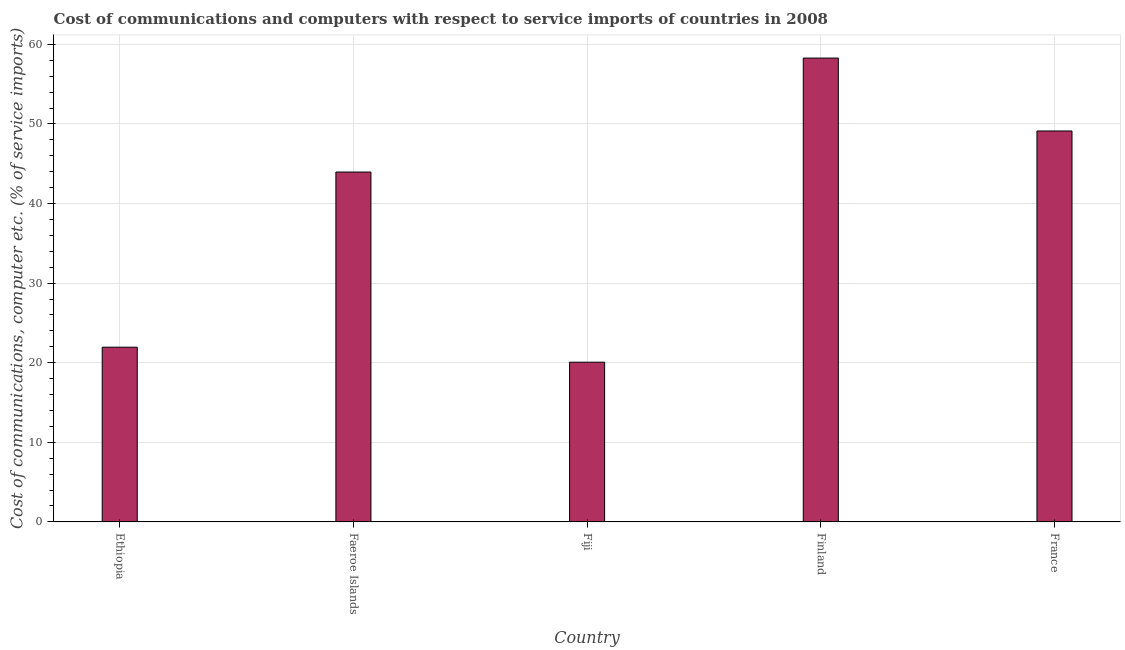Does the graph contain grids?
Give a very brief answer. Yes. What is the title of the graph?
Make the answer very short. Cost of communications and computers with respect to service imports of countries in 2008. What is the label or title of the X-axis?
Ensure brevity in your answer.  Country. What is the label or title of the Y-axis?
Provide a short and direct response. Cost of communications, computer etc. (% of service imports). What is the cost of communications and computer in Fiji?
Provide a succinct answer. 20.07. Across all countries, what is the maximum cost of communications and computer?
Your response must be concise. 58.28. Across all countries, what is the minimum cost of communications and computer?
Provide a short and direct response. 20.07. In which country was the cost of communications and computer minimum?
Offer a very short reply. Fiji. What is the sum of the cost of communications and computer?
Offer a very short reply. 193.37. What is the difference between the cost of communications and computer in Faeroe Islands and France?
Your response must be concise. -5.16. What is the average cost of communications and computer per country?
Offer a very short reply. 38.67. What is the median cost of communications and computer?
Your response must be concise. 43.96. In how many countries, is the cost of communications and computer greater than 38 %?
Offer a very short reply. 3. What is the ratio of the cost of communications and computer in Ethiopia to that in Finland?
Provide a succinct answer. 0.38. Is the cost of communications and computer in Faeroe Islands less than that in Finland?
Offer a terse response. Yes. Is the difference between the cost of communications and computer in Faeroe Islands and Finland greater than the difference between any two countries?
Give a very brief answer. No. What is the difference between the highest and the second highest cost of communications and computer?
Offer a terse response. 9.16. What is the difference between the highest and the lowest cost of communications and computer?
Provide a short and direct response. 38.21. How many bars are there?
Keep it short and to the point. 5. Are all the bars in the graph horizontal?
Offer a very short reply. No. How many countries are there in the graph?
Make the answer very short. 5. What is the Cost of communications, computer etc. (% of service imports) in Ethiopia?
Provide a short and direct response. 21.95. What is the Cost of communications, computer etc. (% of service imports) of Faeroe Islands?
Provide a succinct answer. 43.96. What is the Cost of communications, computer etc. (% of service imports) in Fiji?
Offer a terse response. 20.07. What is the Cost of communications, computer etc. (% of service imports) in Finland?
Your answer should be very brief. 58.28. What is the Cost of communications, computer etc. (% of service imports) in France?
Offer a terse response. 49.12. What is the difference between the Cost of communications, computer etc. (% of service imports) in Ethiopia and Faeroe Islands?
Give a very brief answer. -22. What is the difference between the Cost of communications, computer etc. (% of service imports) in Ethiopia and Fiji?
Give a very brief answer. 1.88. What is the difference between the Cost of communications, computer etc. (% of service imports) in Ethiopia and Finland?
Your response must be concise. -36.32. What is the difference between the Cost of communications, computer etc. (% of service imports) in Ethiopia and France?
Offer a very short reply. -27.16. What is the difference between the Cost of communications, computer etc. (% of service imports) in Faeroe Islands and Fiji?
Give a very brief answer. 23.89. What is the difference between the Cost of communications, computer etc. (% of service imports) in Faeroe Islands and Finland?
Offer a terse response. -14.32. What is the difference between the Cost of communications, computer etc. (% of service imports) in Faeroe Islands and France?
Offer a very short reply. -5.16. What is the difference between the Cost of communications, computer etc. (% of service imports) in Fiji and Finland?
Offer a very short reply. -38.21. What is the difference between the Cost of communications, computer etc. (% of service imports) in Fiji and France?
Keep it short and to the point. -29.05. What is the difference between the Cost of communications, computer etc. (% of service imports) in Finland and France?
Offer a very short reply. 9.16. What is the ratio of the Cost of communications, computer etc. (% of service imports) in Ethiopia to that in Faeroe Islands?
Keep it short and to the point. 0.5. What is the ratio of the Cost of communications, computer etc. (% of service imports) in Ethiopia to that in Fiji?
Your response must be concise. 1.09. What is the ratio of the Cost of communications, computer etc. (% of service imports) in Ethiopia to that in Finland?
Offer a very short reply. 0.38. What is the ratio of the Cost of communications, computer etc. (% of service imports) in Ethiopia to that in France?
Provide a succinct answer. 0.45. What is the ratio of the Cost of communications, computer etc. (% of service imports) in Faeroe Islands to that in Fiji?
Your answer should be very brief. 2.19. What is the ratio of the Cost of communications, computer etc. (% of service imports) in Faeroe Islands to that in Finland?
Make the answer very short. 0.75. What is the ratio of the Cost of communications, computer etc. (% of service imports) in Faeroe Islands to that in France?
Offer a terse response. 0.9. What is the ratio of the Cost of communications, computer etc. (% of service imports) in Fiji to that in Finland?
Provide a succinct answer. 0.34. What is the ratio of the Cost of communications, computer etc. (% of service imports) in Fiji to that in France?
Provide a short and direct response. 0.41. What is the ratio of the Cost of communications, computer etc. (% of service imports) in Finland to that in France?
Provide a short and direct response. 1.19. 